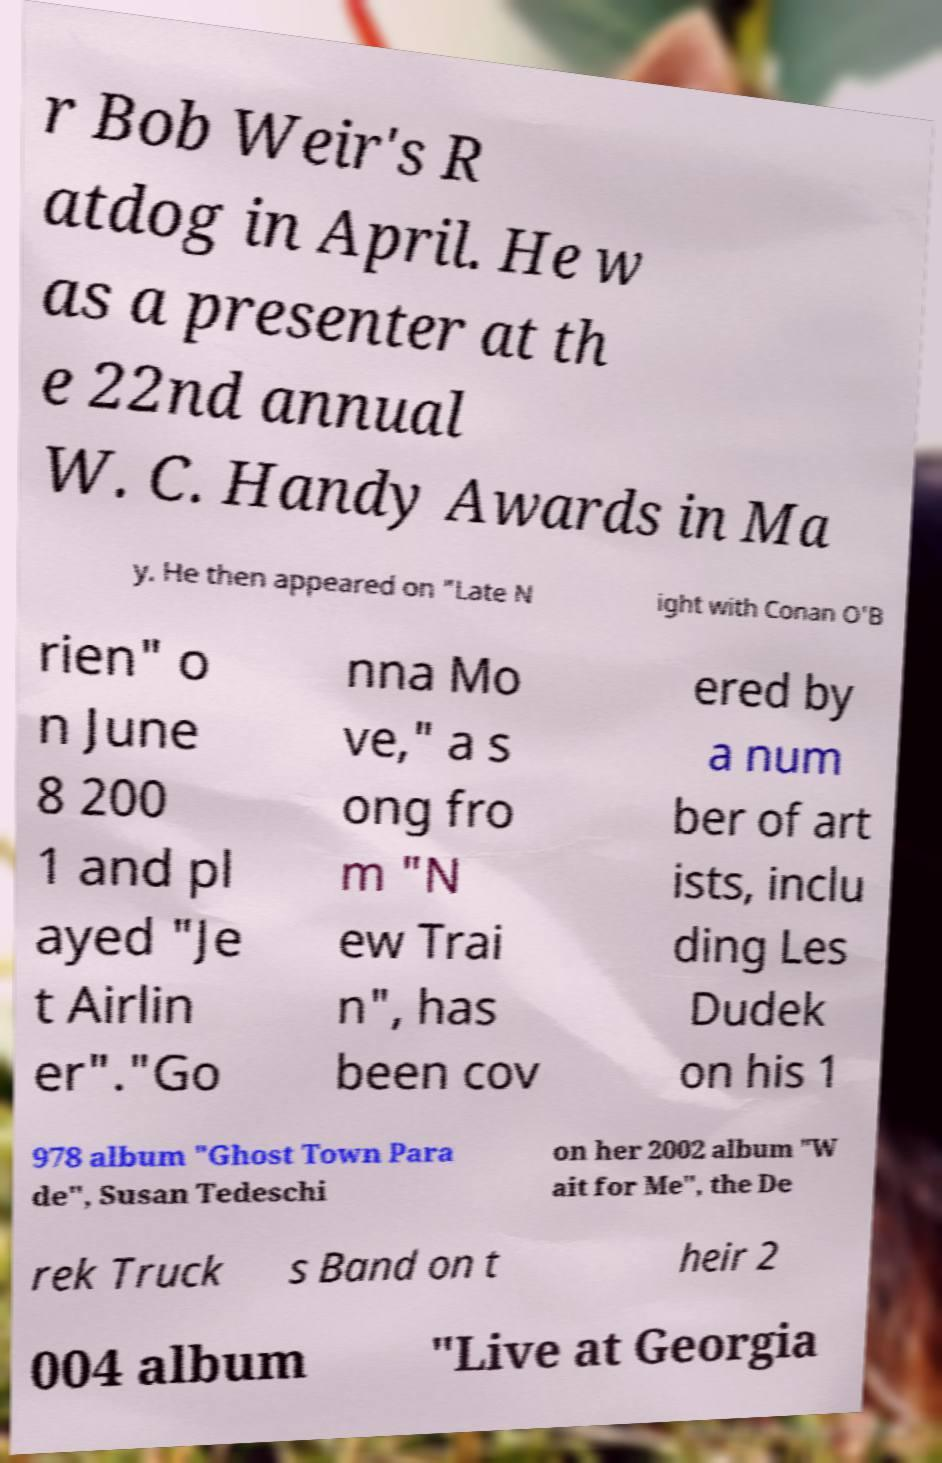For documentation purposes, I need the text within this image transcribed. Could you provide that? r Bob Weir's R atdog in April. He w as a presenter at th e 22nd annual W. C. Handy Awards in Ma y. He then appeared on "Late N ight with Conan O'B rien" o n June 8 200 1 and pl ayed "Je t Airlin er"."Go nna Mo ve," a s ong fro m "N ew Trai n", has been cov ered by a num ber of art ists, inclu ding Les Dudek on his 1 978 album "Ghost Town Para de", Susan Tedeschi on her 2002 album "W ait for Me", the De rek Truck s Band on t heir 2 004 album "Live at Georgia 